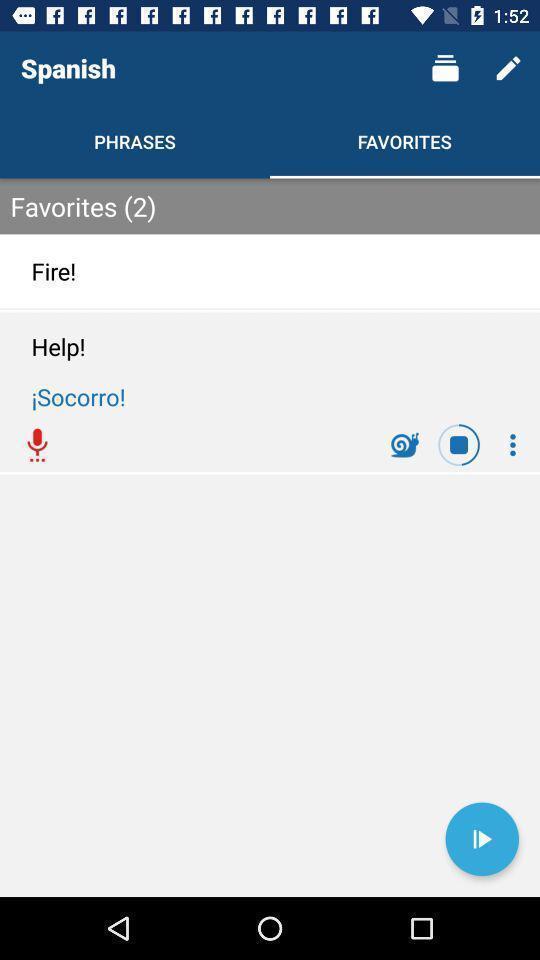Provide a textual representation of this image. Screen displaying multiple controls in a language learning application. 